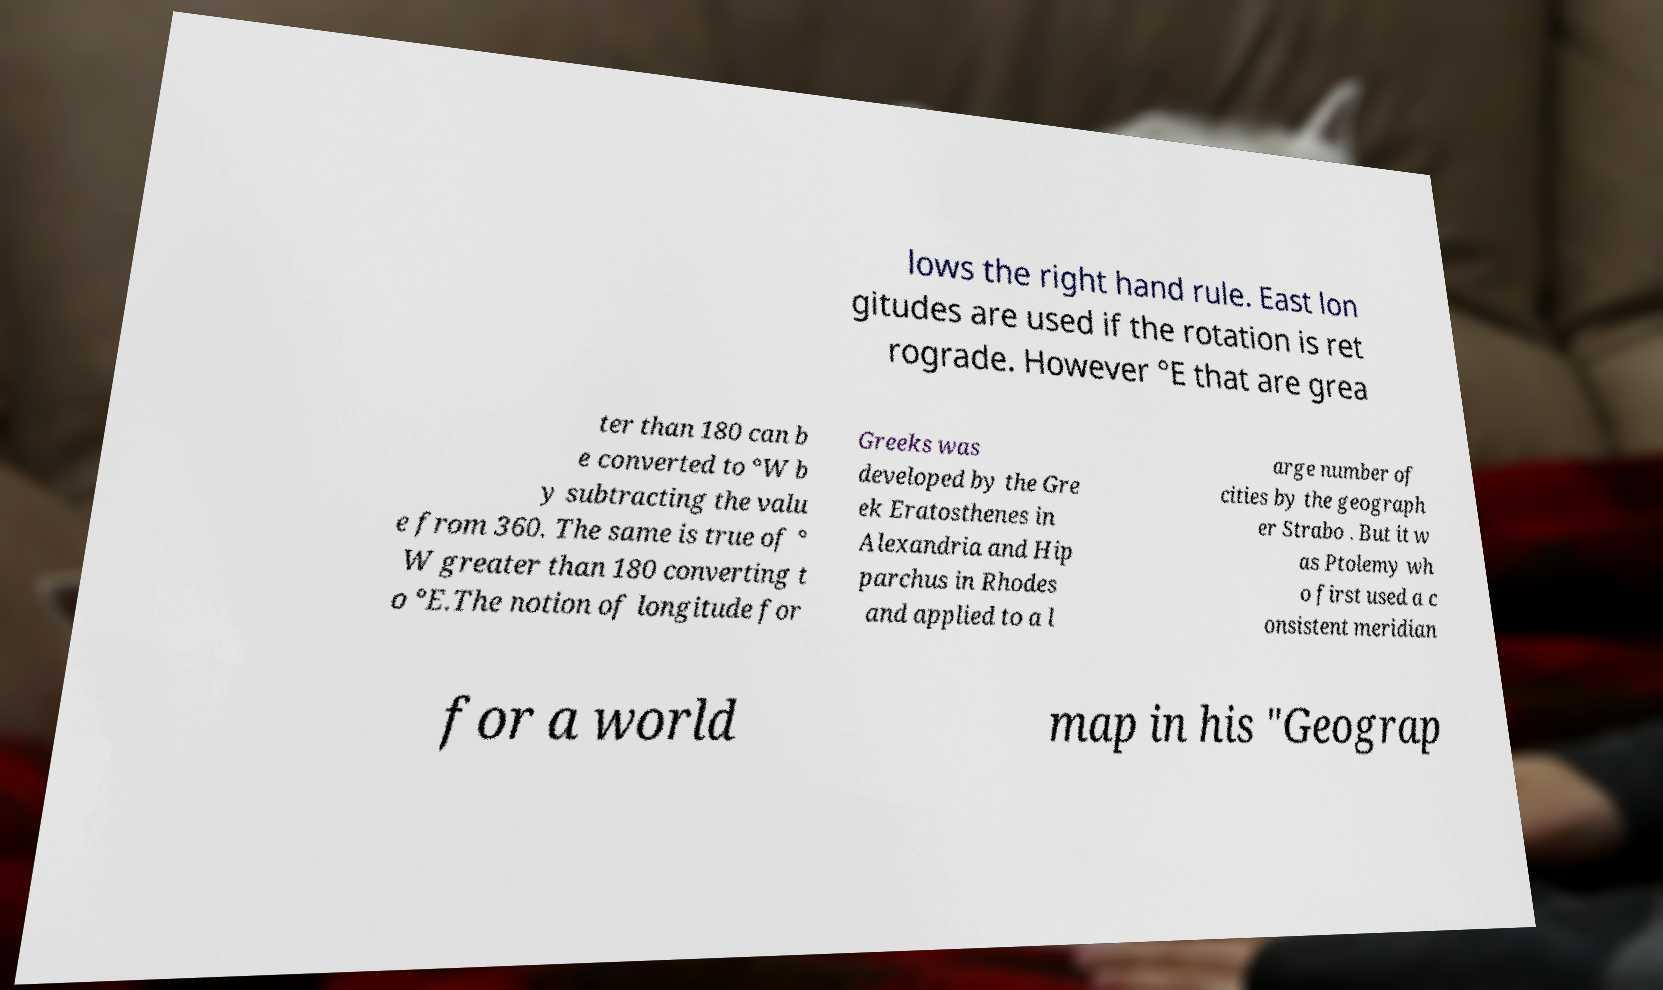Please read and relay the text visible in this image. What does it say? lows the right hand rule. East lon gitudes are used if the rotation is ret rograde. However °E that are grea ter than 180 can b e converted to °W b y subtracting the valu e from 360. The same is true of ° W greater than 180 converting t o °E.The notion of longitude for Greeks was developed by the Gre ek Eratosthenes in Alexandria and Hip parchus in Rhodes and applied to a l arge number of cities by the geograph er Strabo . But it w as Ptolemy wh o first used a c onsistent meridian for a world map in his "Geograp 